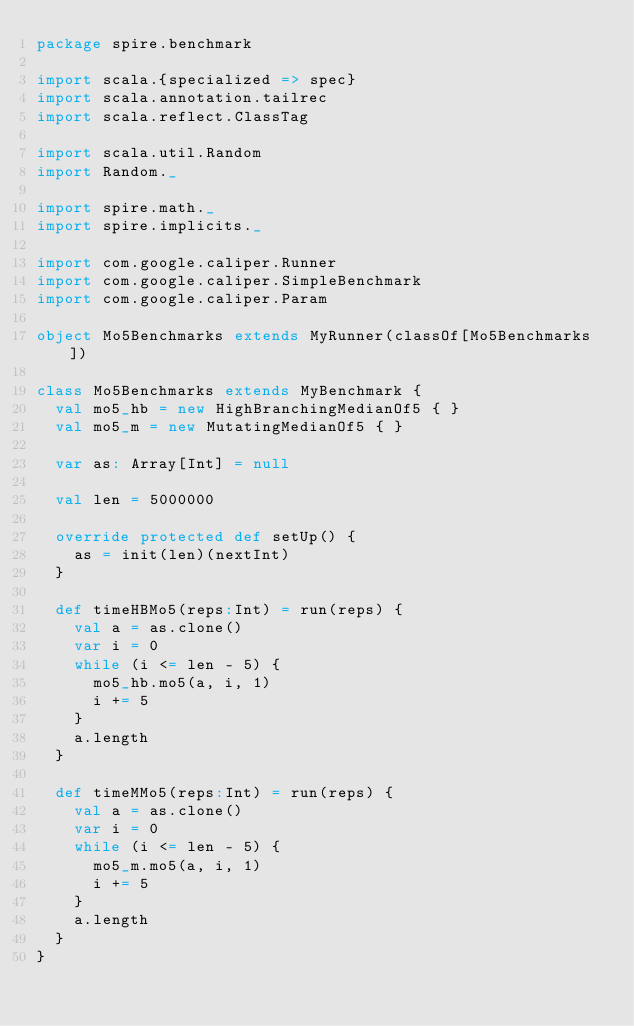<code> <loc_0><loc_0><loc_500><loc_500><_Scala_>package spire.benchmark

import scala.{specialized => spec}
import scala.annotation.tailrec
import scala.reflect.ClassTag

import scala.util.Random
import Random._

import spire.math._
import spire.implicits._

import com.google.caliper.Runner 
import com.google.caliper.SimpleBenchmark
import com.google.caliper.Param

object Mo5Benchmarks extends MyRunner(classOf[Mo5Benchmarks])

class Mo5Benchmarks extends MyBenchmark {
  val mo5_hb = new HighBranchingMedianOf5 { }
  val mo5_m = new MutatingMedianOf5 { }

  var as: Array[Int] = null

  val len = 5000000

  override protected def setUp() {
    as = init(len)(nextInt)
  }

  def timeHBMo5(reps:Int) = run(reps) {
    val a = as.clone()
    var i = 0
    while (i <= len - 5) {
      mo5_hb.mo5(a, i, 1)
      i += 5
    }
    a.length
  }

  def timeMMo5(reps:Int) = run(reps) {
    val a = as.clone()
    var i = 0
    while (i <= len - 5) {
      mo5_m.mo5(a, i, 1)
      i += 5
    }
    a.length
  }
}
</code> 